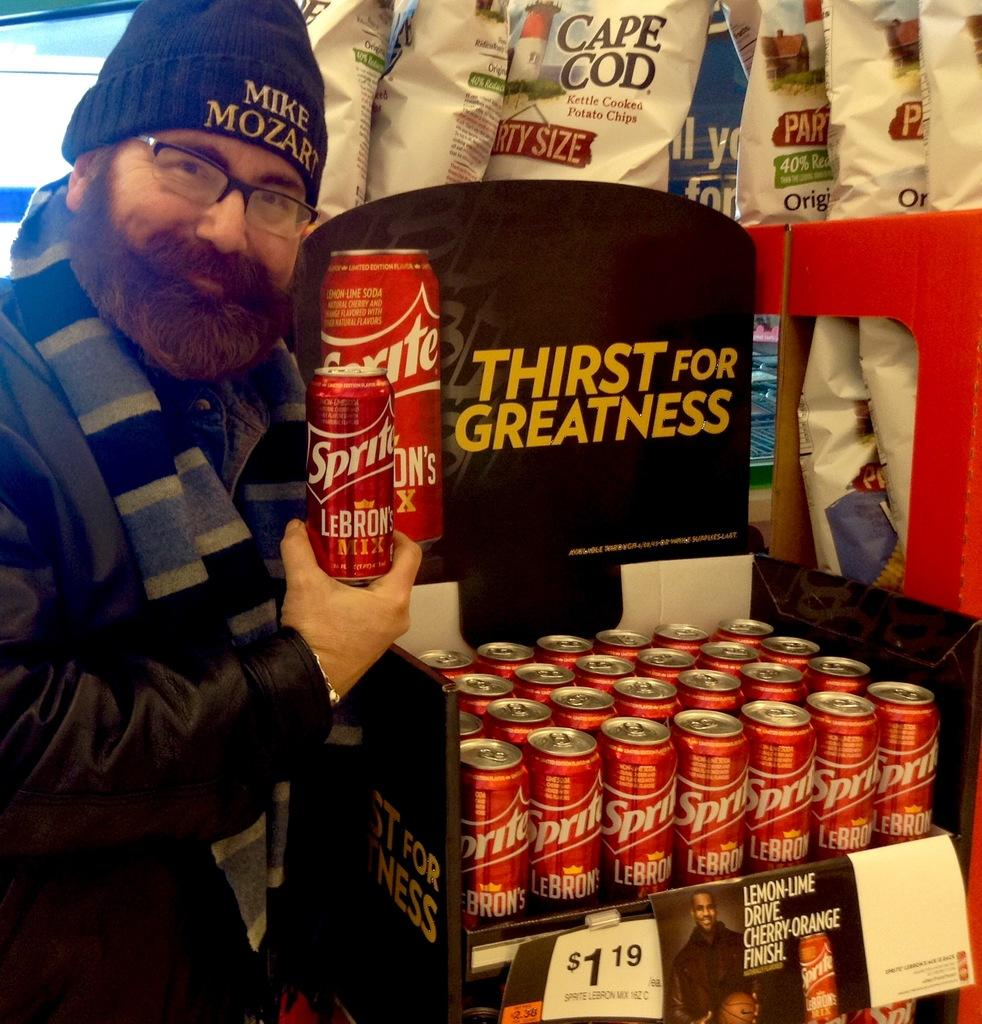<image>
Render a clear and concise summary of the photo. Person holding a red can that says "SPRITE" on it. 